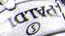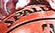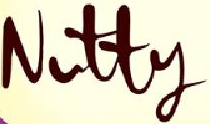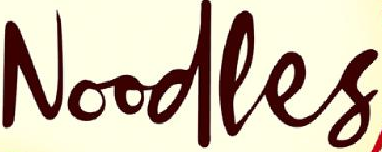What words can you see in these images in sequence, separated by a semicolon? #####; #####; Nutty; Noodles 